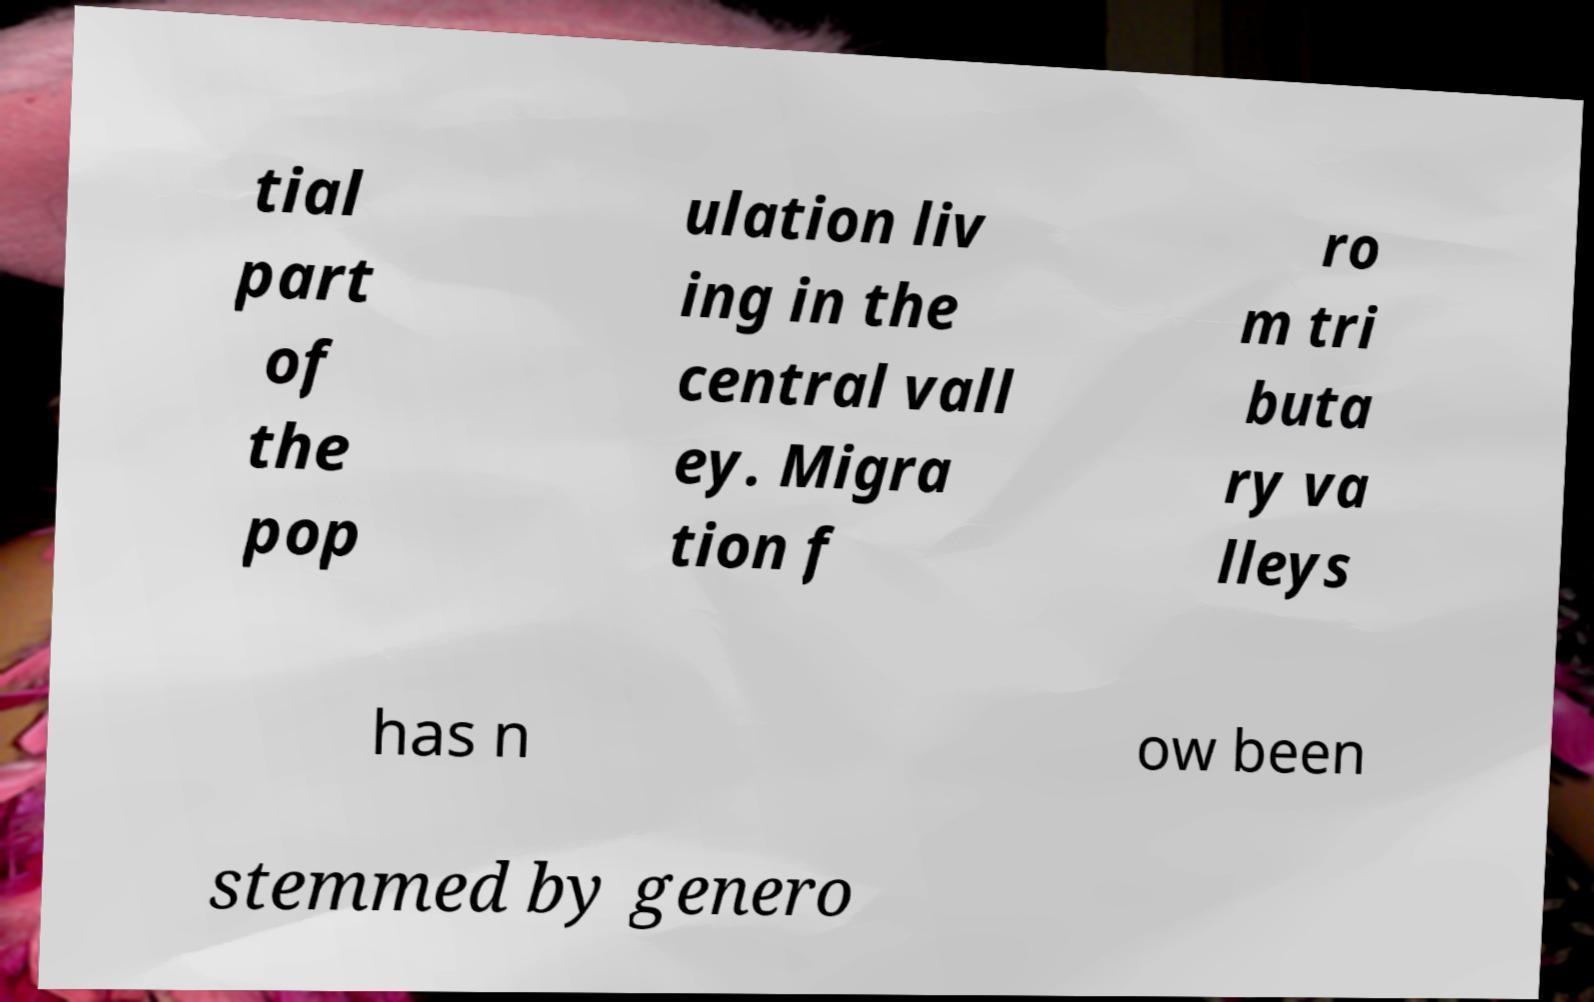For documentation purposes, I need the text within this image transcribed. Could you provide that? tial part of the pop ulation liv ing in the central vall ey. Migra tion f ro m tri buta ry va lleys has n ow been stemmed by genero 